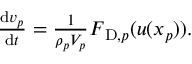Convert formula to latex. <formula><loc_0><loc_0><loc_500><loc_500>\begin{array} { r } { \frac { d v _ { p } } { d t } = \frac { 1 } { \rho _ { p } V _ { p } } F _ { D , p } ( u ( x _ { p } ) ) . } \end{array}</formula> 